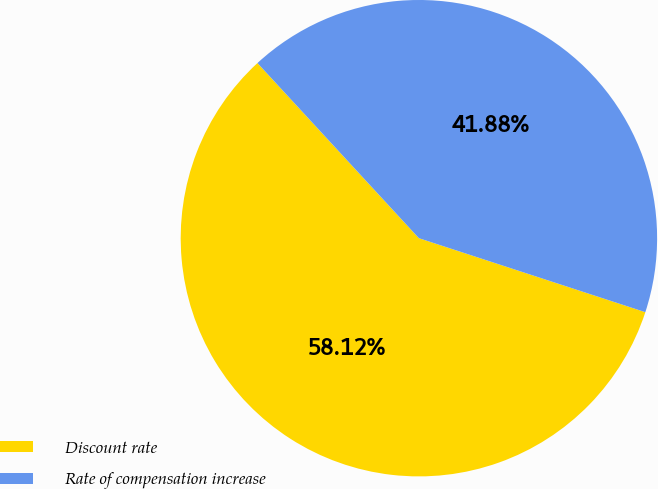Convert chart. <chart><loc_0><loc_0><loc_500><loc_500><pie_chart><fcel>Discount rate<fcel>Rate of compensation increase<nl><fcel>58.12%<fcel>41.88%<nl></chart> 